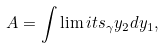<formula> <loc_0><loc_0><loc_500><loc_500>A = \int \lim i t s _ { \gamma } y _ { 2 } d y _ { 1 } ,</formula> 